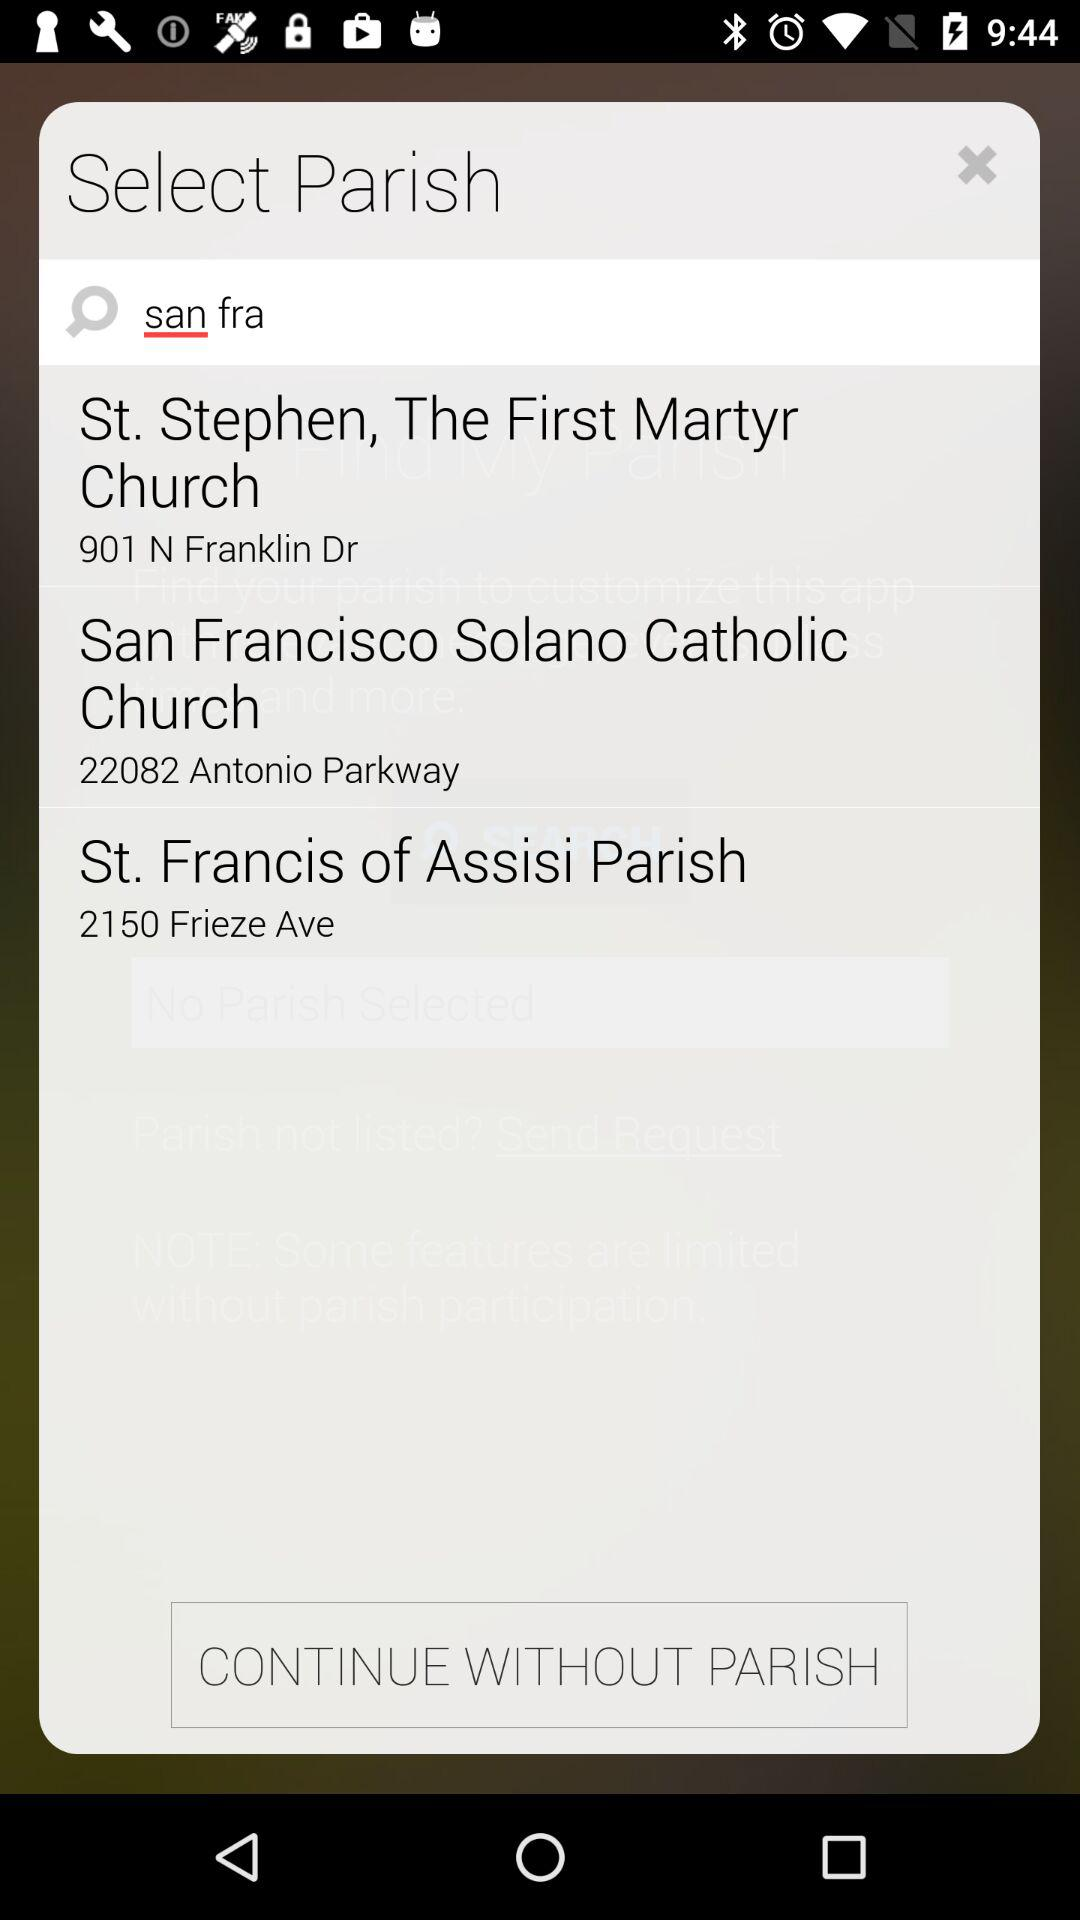Where is the "San Francisco Salano Catholic Church" located? "San Francisco Salano Catholic Church" is located at 22082 Antonio Parkway. 